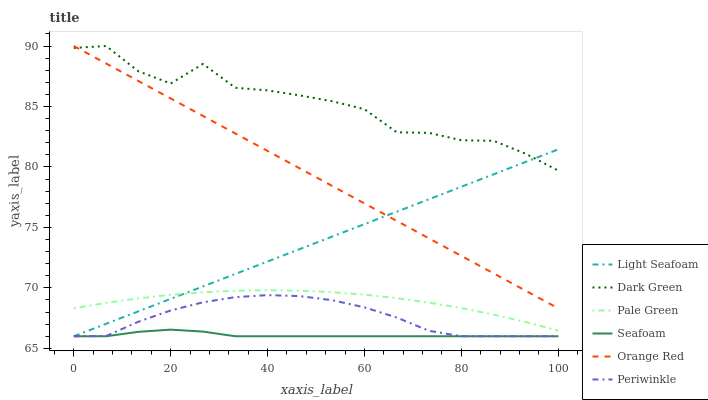Does Pale Green have the minimum area under the curve?
Answer yes or no. No. Does Pale Green have the maximum area under the curve?
Answer yes or no. No. Is Pale Green the smoothest?
Answer yes or no. No. Is Pale Green the roughest?
Answer yes or no. No. Does Pale Green have the lowest value?
Answer yes or no. No. Does Pale Green have the highest value?
Answer yes or no. No. Is Seafoam less than Orange Red?
Answer yes or no. Yes. Is Dark Green greater than Seafoam?
Answer yes or no. Yes. Does Seafoam intersect Orange Red?
Answer yes or no. No. 